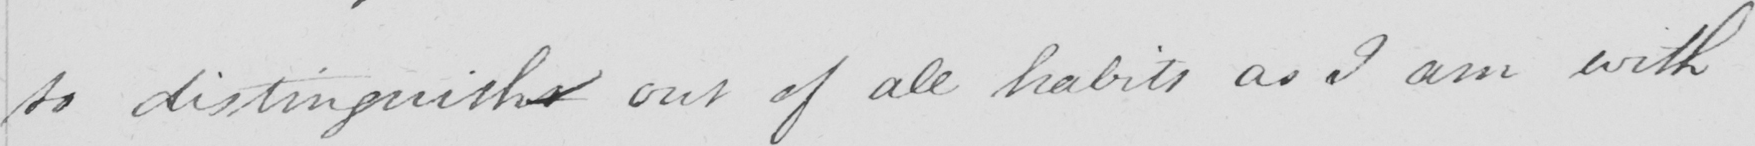What is written in this line of handwriting? to distinguishs out of all habits as I am with 